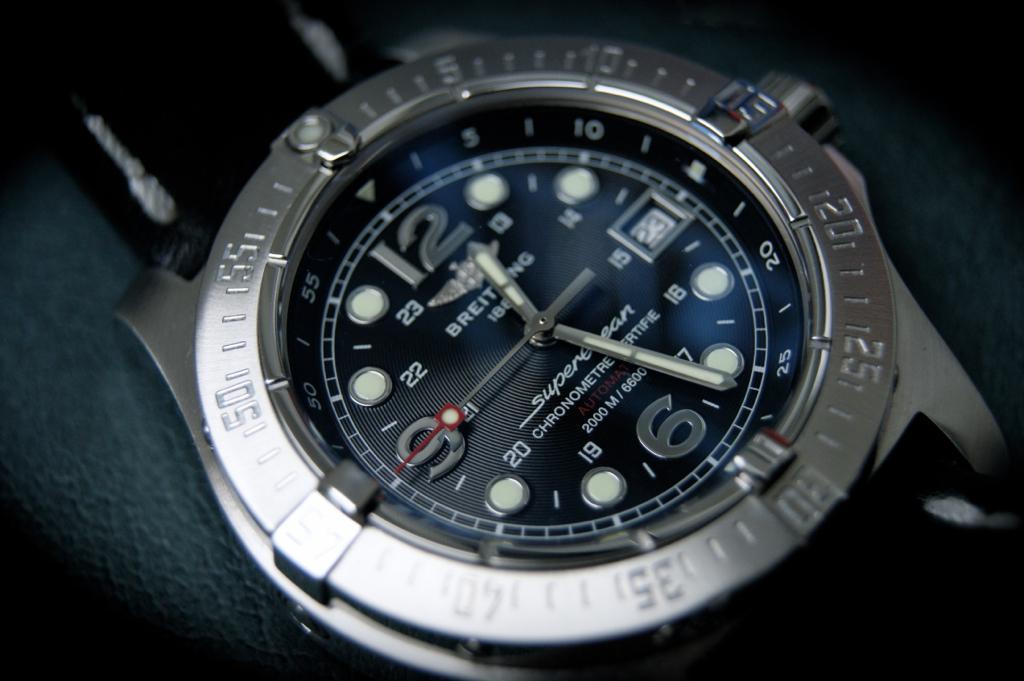What brand of watch is this?
Provide a succinct answer. Breitling. What number does the minute hand point toward?
Give a very brief answer. 25. 